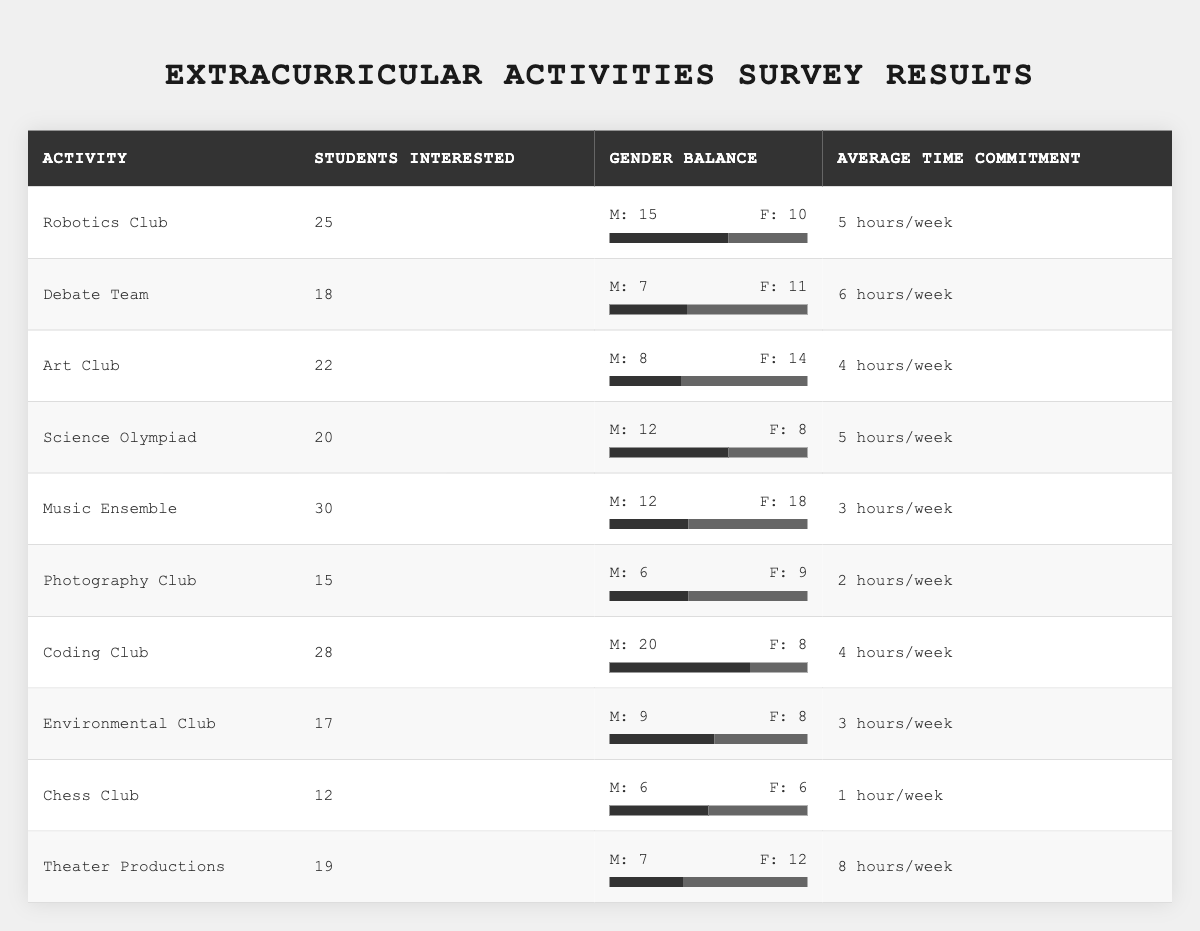What is the activity with the highest number of students interested? By examining the "Students Interested" column, I can see that "Music Ensemble" has the highest number of students interested, with 30 students.
Answer: Music Ensemble How many students are interested in the Coding Club? Referring to the "Students Interested" column for the Coding Club, I find that 28 students are interested in this activity.
Answer: 28 What is the average time commitment for the Art Club? According to the table, the average time commitment for the Art Club is listed as "4 hours/week."
Answer: 4 hours/week Which activity has a higher female representation, Debate Team or Environmental Club? In the Debate Team, there are 11 females, while in the Environmental Club, there are 8 females. Since 11 is greater than 8, the Debate Team has a higher female representation.
Answer: Debate Team Calculate the total number of students interested in sports-related activities (Robotics, Debate, and Science Olympiad). Adding the number of students interested in each of these activities: Robotics (25) + Debate Team (18) + Science Olympiad (20) = 63.
Answer: 63 Is there a majority of males in the Coding Club? In the Coding Club, there are 20 males out of 28 total students (20 males and 8 females). Since 20 exceeds half of 28, there is a majority of males in the Coding Club.
Answer: Yes What is the difference in student interest between the Music Ensemble and the Chess Club? The Music Ensemble has 30 students interested, while the Chess Club has 12. The difference is 30 - 12 = 18.
Answer: 18 On average, which activity requires the least amount of time commitment? The activities with the least time commitment are Chess Club (1 hour/week) and Photography Club (2 hours/week). The Chess Club has the least commitment, at 1 hour/week.
Answer: Chess Club How many total students are interested in all the extracurricular activities combined? Adding all students interested: 25 (Robotics) + 18 (Debate) + 22 (Art) + 20 (Science Olympiad) + 30 (Music) + 15 (Photography) + 28 (Coding) + 17 (Environmental) + 12 (Chess) + 19 (Theater) =  295.
Answer: 295 Which extracurricular activity has the least number of students interested? By checking the "Students Interested" column, I find that the Chess Club has the least number of students interested, with only 12.
Answer: Chess Club 